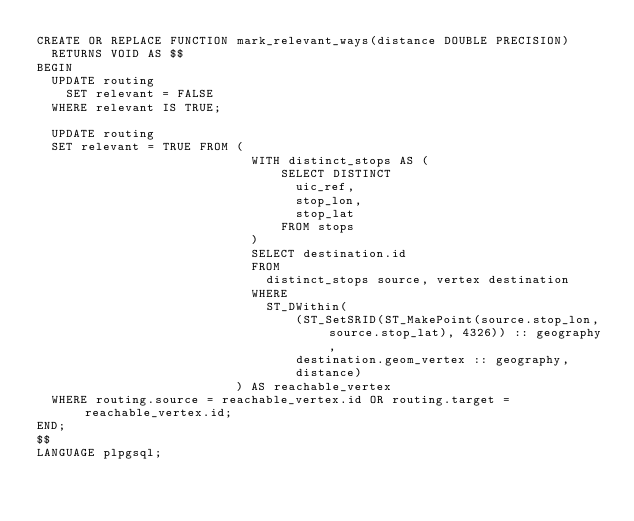Convert code to text. <code><loc_0><loc_0><loc_500><loc_500><_SQL_>CREATE OR REPLACE FUNCTION mark_relevant_ways(distance DOUBLE PRECISION)
  RETURNS VOID AS $$
BEGIN
  UPDATE routing
    SET relevant = FALSE
  WHERE relevant IS TRUE;

  UPDATE routing
  SET relevant = TRUE FROM (
                             WITH distinct_stops AS (
                                 SELECT DISTINCT
                                   uic_ref,
                                   stop_lon,
                                   stop_lat
                                 FROM stops
                             )
                             SELECT destination.id
                             FROM
                               distinct_stops source, vertex destination
                             WHERE
                               ST_DWithin(
                                   (ST_SetSRID(ST_MakePoint(source.stop_lon, source.stop_lat), 4326)) :: geography,
                                   destination.geom_vertex :: geography,
                                   distance)
                           ) AS reachable_vertex
  WHERE routing.source = reachable_vertex.id OR routing.target = reachable_vertex.id;
END;
$$
LANGUAGE plpgsql;</code> 